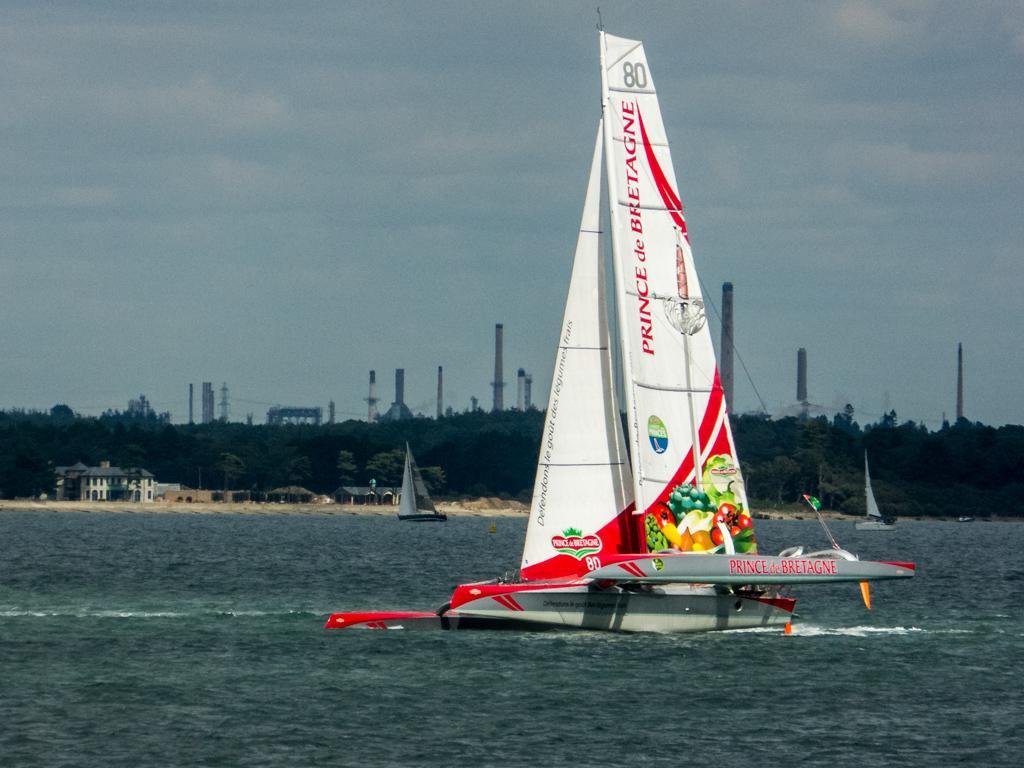Can you describe this image briefly? In this image, we can see boats on the water and in the background, there are trees, buildings and towers. At the top, there is sky. 